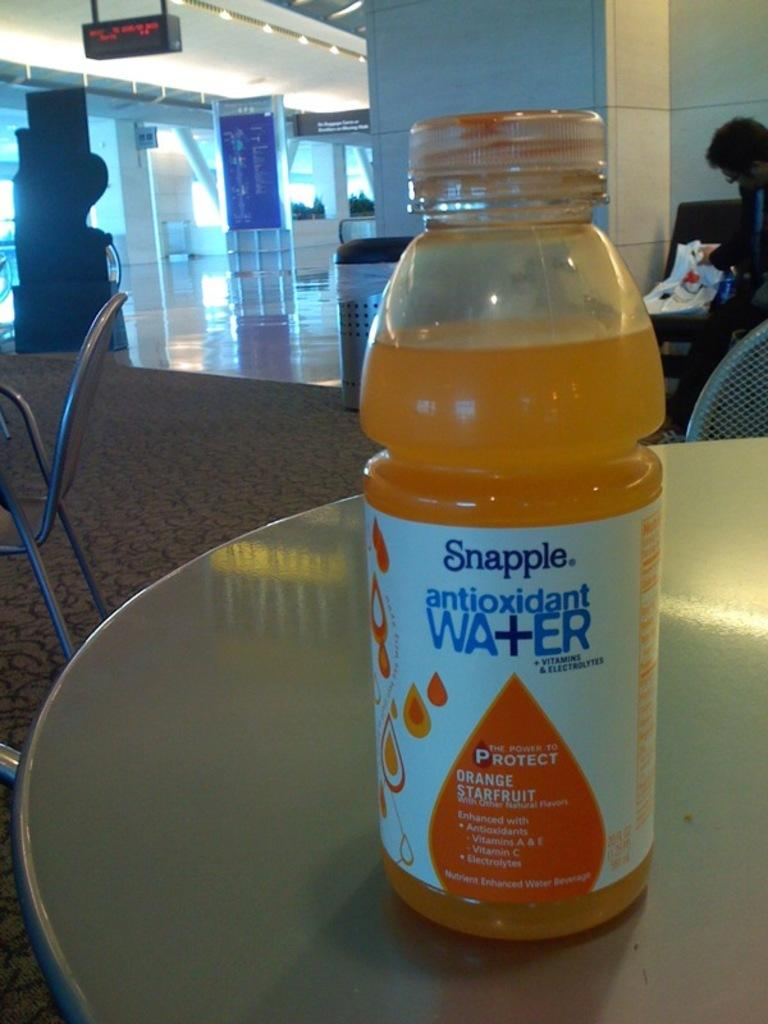<image>
Render a clear and concise summary of the photo. A bottle of Snapple antioxidant water in the flavor Orange Starfruit. 